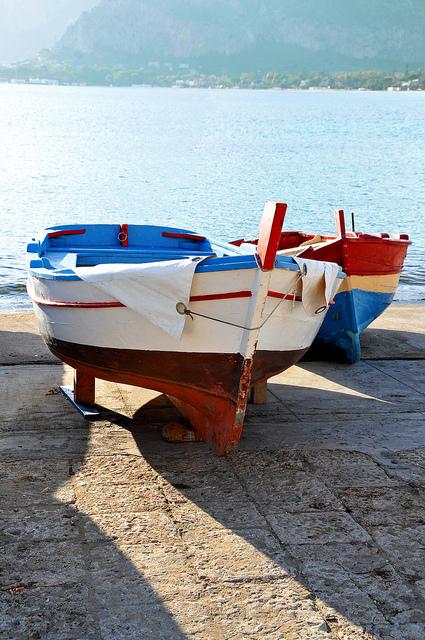Are the boats on wheels?
Short answer required. No. Could these bright boats be near the Mediterranean Sea?
Give a very brief answer. Yes. How many boats are pictured?
Be succinct. 2. 